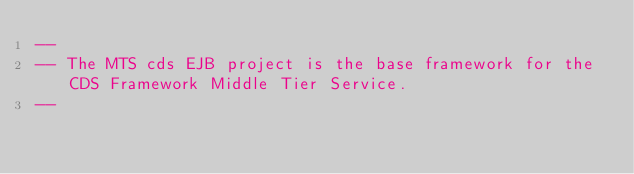Convert code to text. <code><loc_0><loc_0><loc_500><loc_500><_SQL_>--
-- The MTS cds EJB project is the base framework for the CDS Framework Middle Tier Service.
--</code> 